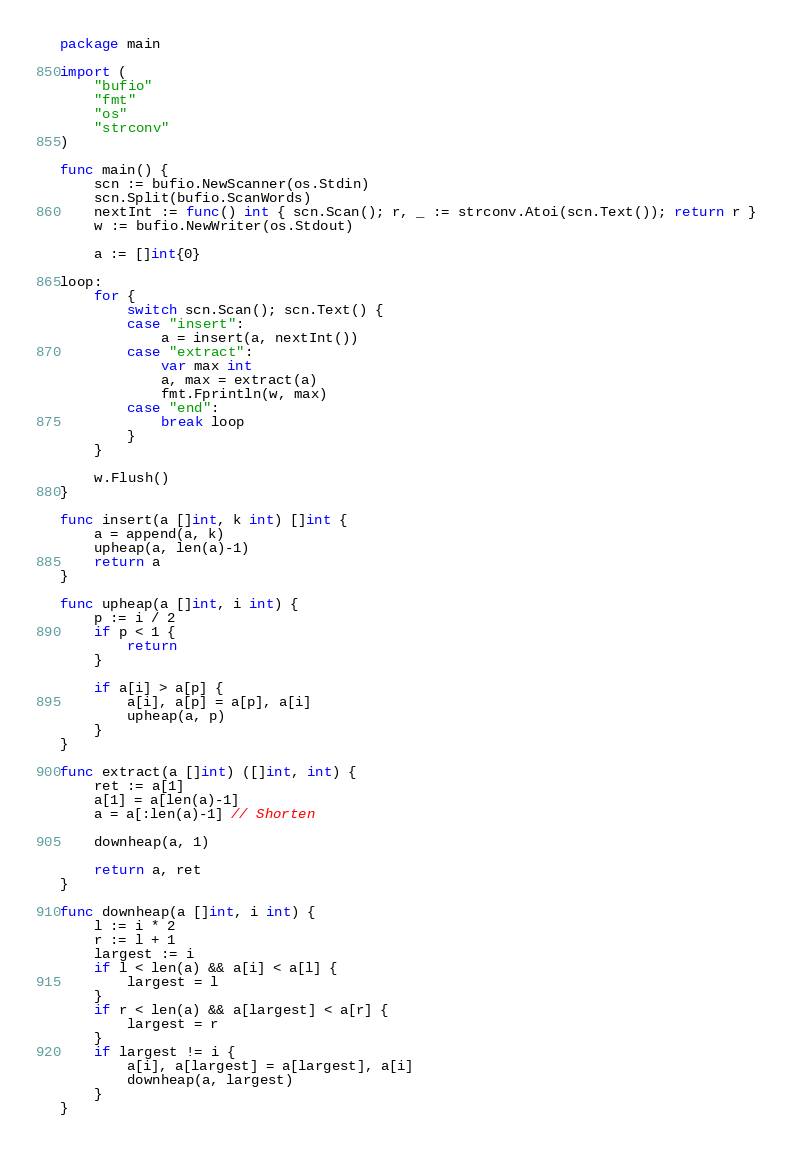Convert code to text. <code><loc_0><loc_0><loc_500><loc_500><_Go_>package main

import (
	"bufio"
	"fmt"
	"os"
	"strconv"
)

func main() {
	scn := bufio.NewScanner(os.Stdin)
	scn.Split(bufio.ScanWords)
	nextInt := func() int { scn.Scan(); r, _ := strconv.Atoi(scn.Text()); return r }
	w := bufio.NewWriter(os.Stdout)

	a := []int{0}

loop:
	for {
		switch scn.Scan(); scn.Text() {
		case "insert":
			a = insert(a, nextInt())
		case "extract":
			var max int
			a, max = extract(a)
			fmt.Fprintln(w, max)
		case "end":
			break loop
		}
	}

	w.Flush()
}

func insert(a []int, k int) []int {
	a = append(a, k)
	upheap(a, len(a)-1)
	return a
}

func upheap(a []int, i int) {
	p := i / 2
	if p < 1 {
		return
	}

	if a[i] > a[p] {
		a[i], a[p] = a[p], a[i]
		upheap(a, p)
	}
}

func extract(a []int) ([]int, int) {
	ret := a[1]
	a[1] = a[len(a)-1]
	a = a[:len(a)-1] // Shorten

	downheap(a, 1)

	return a, ret
}

func downheap(a []int, i int) {
	l := i * 2
	r := l + 1
	largest := i
	if l < len(a) && a[i] < a[l] {
		largest = l
	}
	if r < len(a) && a[largest] < a[r] {
		largest = r
	}
	if largest != i {
		a[i], a[largest] = a[largest], a[i]
		downheap(a, largest)
	}
}

</code> 